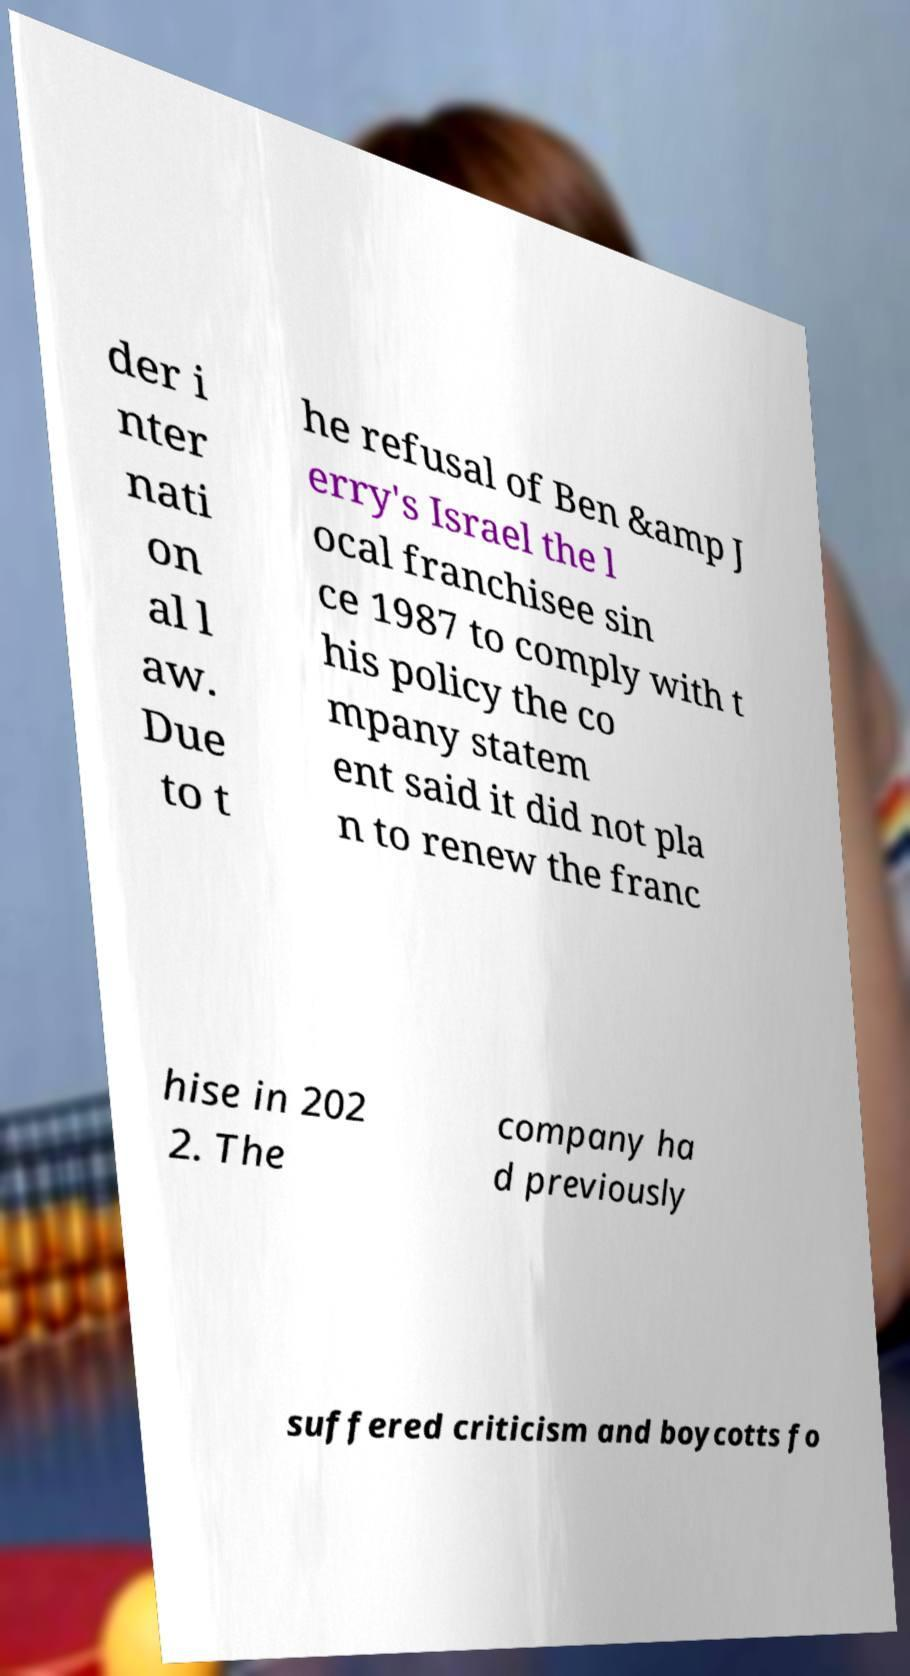Could you assist in decoding the text presented in this image and type it out clearly? der i nter nati on al l aw. Due to t he refusal of Ben &amp J erry's Israel the l ocal franchisee sin ce 1987 to comply with t his policy the co mpany statem ent said it did not pla n to renew the franc hise in 202 2. The company ha d previously suffered criticism and boycotts fo 